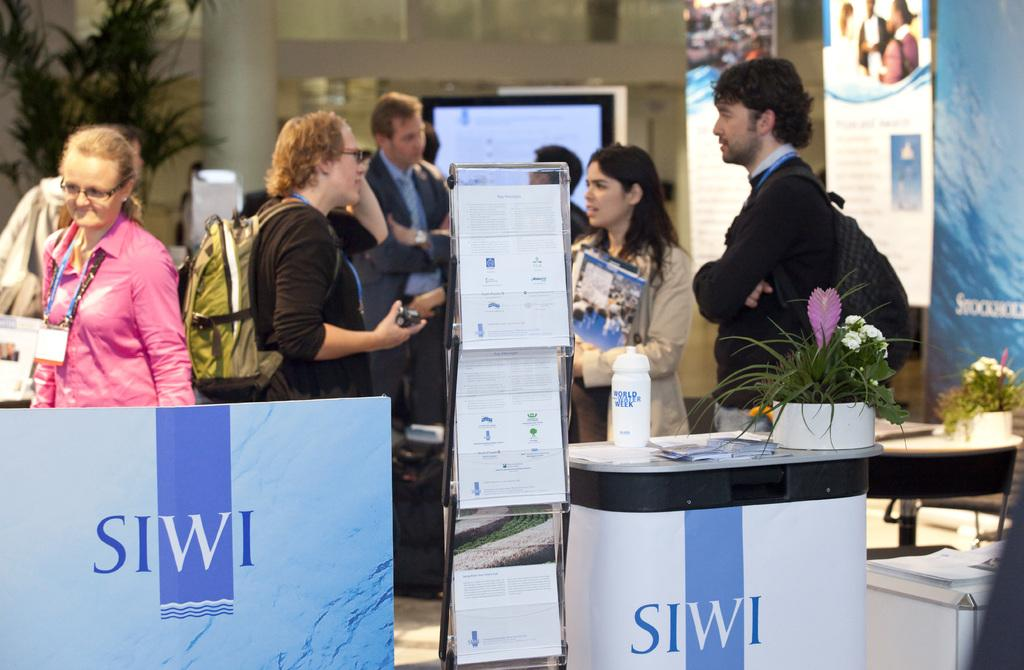<image>
Summarize the visual content of the image. People mill about talking at the SIWI booth at a conference. 